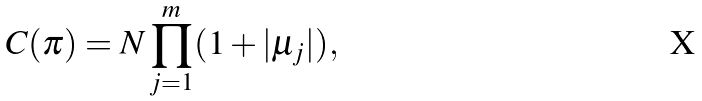Convert formula to latex. <formula><loc_0><loc_0><loc_500><loc_500>C ( \pi ) = N \prod _ { j = 1 } ^ { m } ( 1 + | \mu _ { j } | ) ,</formula> 